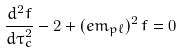<formula> <loc_0><loc_0><loc_500><loc_500>\frac { d ^ { 2 } f } { d \tau ^ { 2 } _ { c } } - 2 + ( e m _ { p \ell } ) ^ { 2 } \, f = 0</formula> 